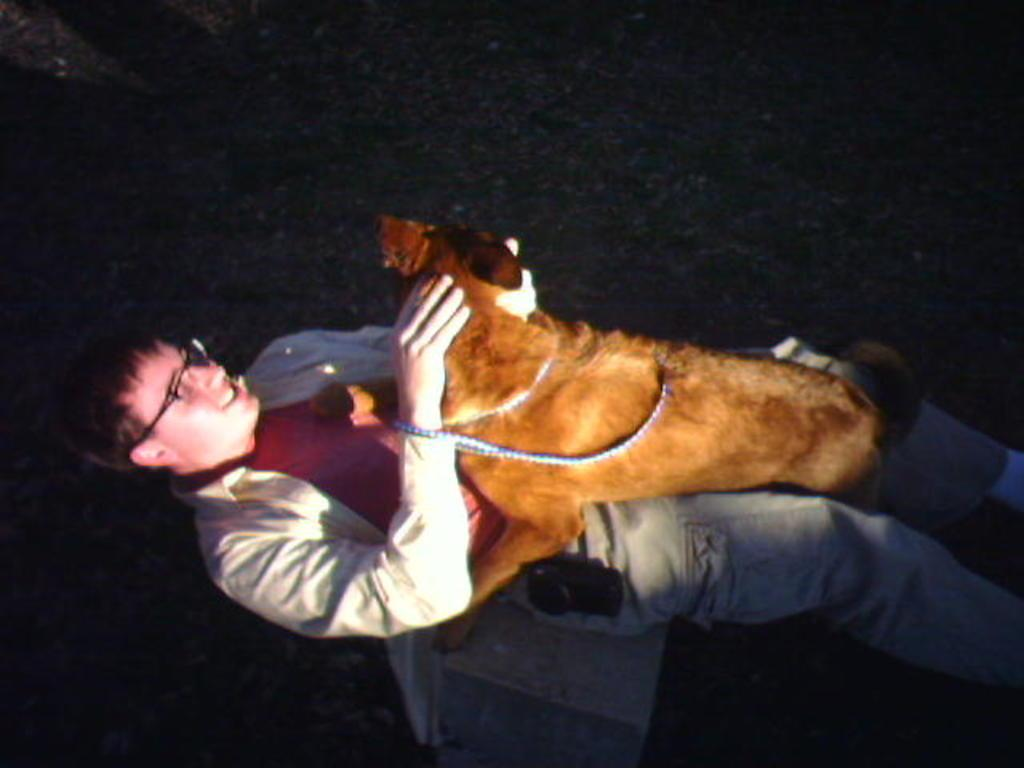What is the main subject in the foreground of the picture? There is a man lying on the grass in the foreground of the picture. Is there any other living creature in the image? Yes, there is a dog on the man. How would you describe the lighting in the image? The image appears to be dark. Can you see any monkeys playing in the sand in the image? No, there are no monkeys or sand present in the image. How many pizzas are being delivered in the image? There is no mention of pizzas or delivery in the image. 